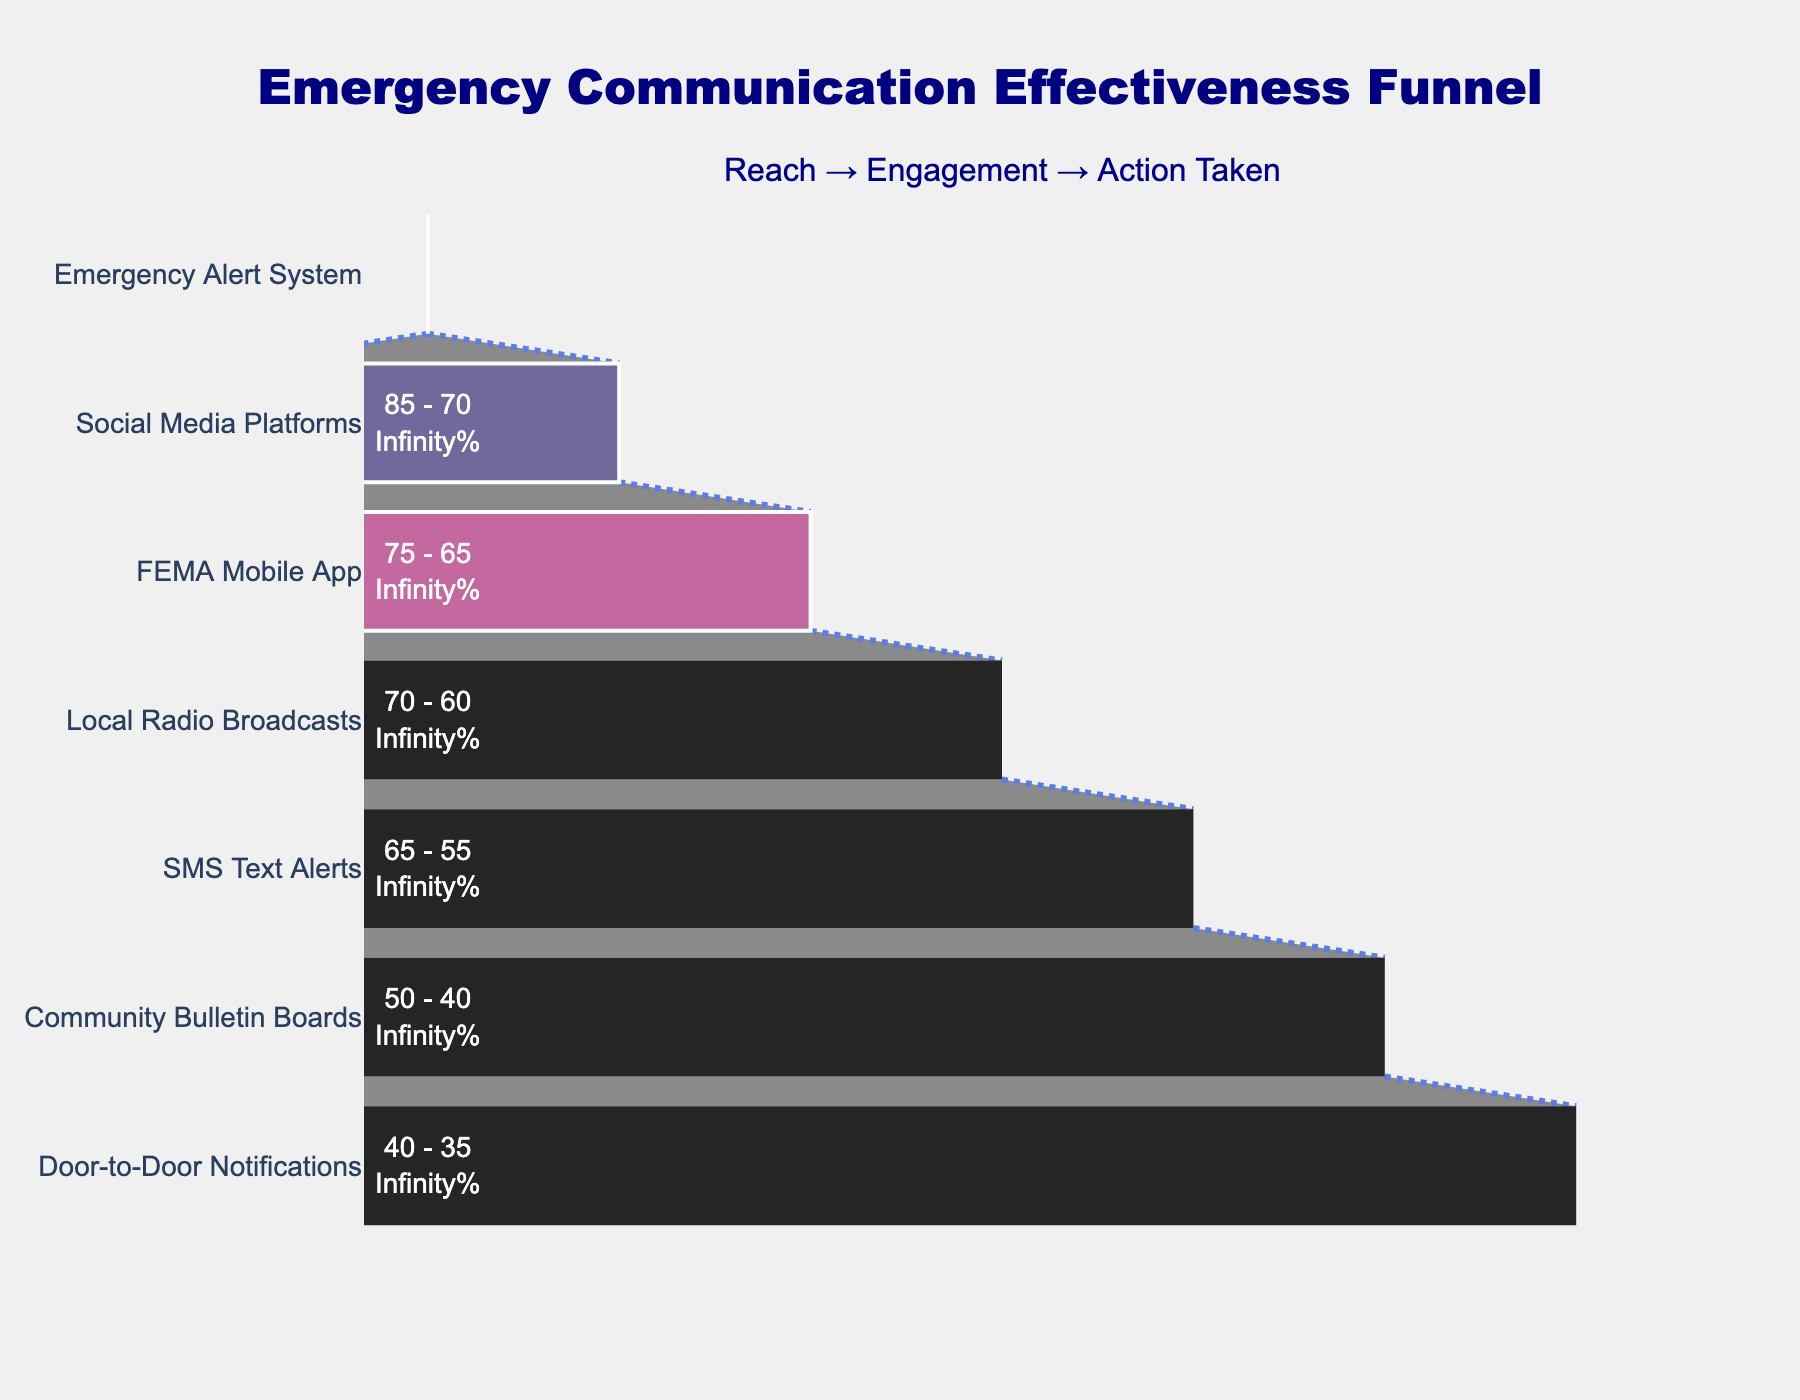What is the title of the funnel chart? The title is located at the top of the chart and is meant to provide an overview of what the chart represents.
Answer: Emergency Communication Effectiveness Funnel Which communication channel has the highest reach percentage? The reach percentage can be observed on the left side of the chart. The channel with the highest value is the one with the 95% reach.
Answer: Emergency Alert System What is the difference in engagement percentage between Social Media Platforms and Local Radio Broadcasts? Look at the engagement percentages for Social Media Platforms (70%) and Local Radio Broadcasts (60%). Subtract the smaller from the larger value: 70% - 60% = 10%.
Answer: 10% Which communication channel has the least percentage of action taken? The percentage of action taken is indicated in the final stage of the funnel. The channel with the lowest value here is Door-to-Door Notifications with 25%.
Answer: Door-to-Door Notifications How does the FEMA Mobile App compare to SMS Text Alerts in terms of reach and engagement percentages? For reach, FEMA Mobile App has 75% and SMS Text Alerts have 65%. For engagement, FEMA Mobile App has 65% and SMS Text Alerts have 55%. The FEMA Mobile App has higher percentages in both metrics.
Answer: FEMA Mobile App has higher reach and engagement What are the colors used in the different sections of the funnel chart? The colors are used to represent different metrics in the funnel (reach, engagement, action taken). These colors are dark blue, purple, and pink respectively.
Answer: Dark blue, purple, pink Which stage shows the biggest drop in percentage from engagement to action taken in any channel? Observe the engagement and action taken percentages for each channel and calculate the difference. The largest drop is from Social Media Platforms with a drop from 70% engagement to 55% action taken, a 15% drop.
Answer: Social Media Platforms What is the average engagement percentage across all communication channels? Sum up the engagement percentages for all channels (80 + 70 + 65 + 60 + 55 + 40 + 35) and divide by the number of channels (7). The total is 405, so the average is 405/7 ≈ 57.86%.
Answer: 57.86% How many channels have a reach percentage greater than 70%? Look at the reach percentages and count how many are above 70%. These are Emergency Alert System, Social Media Platforms, and FEMA Mobile App, totaling three channels.
Answer: 3 